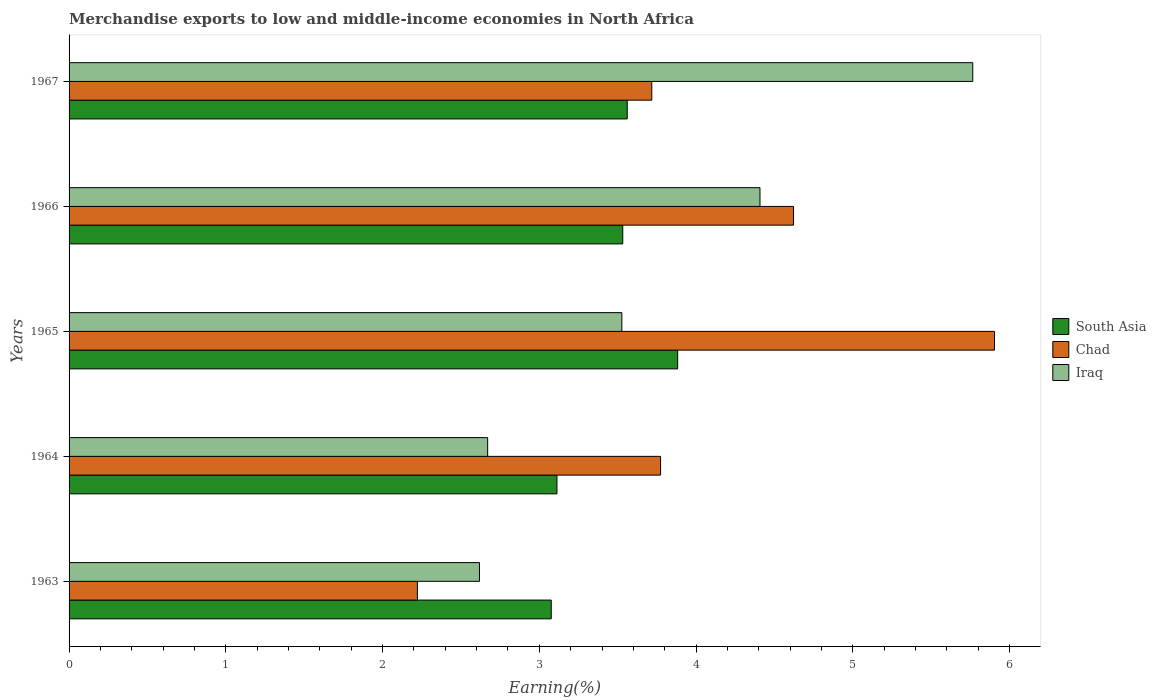How many groups of bars are there?
Provide a short and direct response. 5. Are the number of bars per tick equal to the number of legend labels?
Give a very brief answer. Yes. What is the label of the 1st group of bars from the top?
Your answer should be compact. 1967. In how many cases, is the number of bars for a given year not equal to the number of legend labels?
Your answer should be compact. 0. What is the percentage of amount earned from merchandise exports in Iraq in 1964?
Provide a succinct answer. 2.67. Across all years, what is the maximum percentage of amount earned from merchandise exports in Chad?
Your answer should be very brief. 5.9. Across all years, what is the minimum percentage of amount earned from merchandise exports in South Asia?
Offer a very short reply. 3.08. In which year was the percentage of amount earned from merchandise exports in Iraq maximum?
Provide a succinct answer. 1967. What is the total percentage of amount earned from merchandise exports in South Asia in the graph?
Make the answer very short. 17.16. What is the difference between the percentage of amount earned from merchandise exports in South Asia in 1963 and that in 1965?
Offer a very short reply. -0.81. What is the difference between the percentage of amount earned from merchandise exports in Chad in 1966 and the percentage of amount earned from merchandise exports in South Asia in 1963?
Your answer should be compact. 1.55. What is the average percentage of amount earned from merchandise exports in South Asia per year?
Make the answer very short. 3.43. In the year 1965, what is the difference between the percentage of amount earned from merchandise exports in Chad and percentage of amount earned from merchandise exports in Iraq?
Offer a very short reply. 2.38. In how many years, is the percentage of amount earned from merchandise exports in Iraq greater than 3.6 %?
Your response must be concise. 2. What is the ratio of the percentage of amount earned from merchandise exports in Chad in 1964 to that in 1967?
Offer a terse response. 1.02. What is the difference between the highest and the second highest percentage of amount earned from merchandise exports in Iraq?
Provide a succinct answer. 1.36. What is the difference between the highest and the lowest percentage of amount earned from merchandise exports in Chad?
Keep it short and to the point. 3.68. What does the 2nd bar from the top in 1966 represents?
Your answer should be very brief. Chad. What does the 3rd bar from the bottom in 1966 represents?
Offer a terse response. Iraq. What is the difference between two consecutive major ticks on the X-axis?
Give a very brief answer. 1. Does the graph contain any zero values?
Make the answer very short. No. What is the title of the graph?
Keep it short and to the point. Merchandise exports to low and middle-income economies in North Africa. What is the label or title of the X-axis?
Provide a short and direct response. Earning(%). What is the Earning(%) in South Asia in 1963?
Your answer should be very brief. 3.08. What is the Earning(%) in Chad in 1963?
Your response must be concise. 2.22. What is the Earning(%) of Iraq in 1963?
Your answer should be compact. 2.62. What is the Earning(%) of South Asia in 1964?
Give a very brief answer. 3.11. What is the Earning(%) of Chad in 1964?
Ensure brevity in your answer.  3.77. What is the Earning(%) in Iraq in 1964?
Your response must be concise. 2.67. What is the Earning(%) in South Asia in 1965?
Your answer should be very brief. 3.88. What is the Earning(%) in Chad in 1965?
Offer a terse response. 5.9. What is the Earning(%) in Iraq in 1965?
Provide a short and direct response. 3.53. What is the Earning(%) of South Asia in 1966?
Give a very brief answer. 3.53. What is the Earning(%) of Chad in 1966?
Make the answer very short. 4.62. What is the Earning(%) in Iraq in 1966?
Your answer should be compact. 4.41. What is the Earning(%) of South Asia in 1967?
Provide a short and direct response. 3.56. What is the Earning(%) in Chad in 1967?
Offer a very short reply. 3.72. What is the Earning(%) in Iraq in 1967?
Ensure brevity in your answer.  5.77. Across all years, what is the maximum Earning(%) of South Asia?
Your response must be concise. 3.88. Across all years, what is the maximum Earning(%) in Chad?
Offer a very short reply. 5.9. Across all years, what is the maximum Earning(%) in Iraq?
Your answer should be compact. 5.77. Across all years, what is the minimum Earning(%) of South Asia?
Keep it short and to the point. 3.08. Across all years, what is the minimum Earning(%) of Chad?
Ensure brevity in your answer.  2.22. Across all years, what is the minimum Earning(%) of Iraq?
Give a very brief answer. 2.62. What is the total Earning(%) of South Asia in the graph?
Keep it short and to the point. 17.16. What is the total Earning(%) in Chad in the graph?
Ensure brevity in your answer.  20.24. What is the total Earning(%) of Iraq in the graph?
Provide a short and direct response. 18.99. What is the difference between the Earning(%) in South Asia in 1963 and that in 1964?
Give a very brief answer. -0.04. What is the difference between the Earning(%) in Chad in 1963 and that in 1964?
Give a very brief answer. -1.55. What is the difference between the Earning(%) of Iraq in 1963 and that in 1964?
Ensure brevity in your answer.  -0.05. What is the difference between the Earning(%) of South Asia in 1963 and that in 1965?
Give a very brief answer. -0.81. What is the difference between the Earning(%) in Chad in 1963 and that in 1965?
Keep it short and to the point. -3.68. What is the difference between the Earning(%) in Iraq in 1963 and that in 1965?
Make the answer very short. -0.91. What is the difference between the Earning(%) in South Asia in 1963 and that in 1966?
Make the answer very short. -0.46. What is the difference between the Earning(%) in Chad in 1963 and that in 1966?
Provide a short and direct response. -2.4. What is the difference between the Earning(%) of Iraq in 1963 and that in 1966?
Ensure brevity in your answer.  -1.79. What is the difference between the Earning(%) of South Asia in 1963 and that in 1967?
Your answer should be compact. -0.48. What is the difference between the Earning(%) of Chad in 1963 and that in 1967?
Provide a succinct answer. -1.5. What is the difference between the Earning(%) of Iraq in 1963 and that in 1967?
Make the answer very short. -3.15. What is the difference between the Earning(%) of South Asia in 1964 and that in 1965?
Give a very brief answer. -0.77. What is the difference between the Earning(%) of Chad in 1964 and that in 1965?
Ensure brevity in your answer.  -2.13. What is the difference between the Earning(%) of Iraq in 1964 and that in 1965?
Keep it short and to the point. -0.86. What is the difference between the Earning(%) of South Asia in 1964 and that in 1966?
Give a very brief answer. -0.42. What is the difference between the Earning(%) of Chad in 1964 and that in 1966?
Make the answer very short. -0.85. What is the difference between the Earning(%) of Iraq in 1964 and that in 1966?
Your answer should be very brief. -1.74. What is the difference between the Earning(%) in South Asia in 1964 and that in 1967?
Ensure brevity in your answer.  -0.45. What is the difference between the Earning(%) of Chad in 1964 and that in 1967?
Provide a succinct answer. 0.06. What is the difference between the Earning(%) of Iraq in 1964 and that in 1967?
Provide a short and direct response. -3.09. What is the difference between the Earning(%) in South Asia in 1965 and that in 1966?
Give a very brief answer. 0.35. What is the difference between the Earning(%) of Chad in 1965 and that in 1966?
Your response must be concise. 1.28. What is the difference between the Earning(%) in Iraq in 1965 and that in 1966?
Provide a short and direct response. -0.88. What is the difference between the Earning(%) in South Asia in 1965 and that in 1967?
Make the answer very short. 0.32. What is the difference between the Earning(%) of Chad in 1965 and that in 1967?
Provide a succinct answer. 2.19. What is the difference between the Earning(%) of Iraq in 1965 and that in 1967?
Offer a terse response. -2.24. What is the difference between the Earning(%) in South Asia in 1966 and that in 1967?
Your answer should be very brief. -0.03. What is the difference between the Earning(%) in Chad in 1966 and that in 1967?
Offer a very short reply. 0.9. What is the difference between the Earning(%) in Iraq in 1966 and that in 1967?
Make the answer very short. -1.36. What is the difference between the Earning(%) of South Asia in 1963 and the Earning(%) of Chad in 1964?
Your answer should be compact. -0.7. What is the difference between the Earning(%) of South Asia in 1963 and the Earning(%) of Iraq in 1964?
Your answer should be compact. 0.41. What is the difference between the Earning(%) in Chad in 1963 and the Earning(%) in Iraq in 1964?
Provide a succinct answer. -0.45. What is the difference between the Earning(%) in South Asia in 1963 and the Earning(%) in Chad in 1965?
Ensure brevity in your answer.  -2.83. What is the difference between the Earning(%) in South Asia in 1963 and the Earning(%) in Iraq in 1965?
Your answer should be very brief. -0.45. What is the difference between the Earning(%) in Chad in 1963 and the Earning(%) in Iraq in 1965?
Offer a terse response. -1.3. What is the difference between the Earning(%) in South Asia in 1963 and the Earning(%) in Chad in 1966?
Offer a very short reply. -1.55. What is the difference between the Earning(%) of South Asia in 1963 and the Earning(%) of Iraq in 1966?
Provide a succinct answer. -1.33. What is the difference between the Earning(%) in Chad in 1963 and the Earning(%) in Iraq in 1966?
Make the answer very short. -2.19. What is the difference between the Earning(%) of South Asia in 1963 and the Earning(%) of Chad in 1967?
Ensure brevity in your answer.  -0.64. What is the difference between the Earning(%) in South Asia in 1963 and the Earning(%) in Iraq in 1967?
Your answer should be very brief. -2.69. What is the difference between the Earning(%) of Chad in 1963 and the Earning(%) of Iraq in 1967?
Ensure brevity in your answer.  -3.54. What is the difference between the Earning(%) of South Asia in 1964 and the Earning(%) of Chad in 1965?
Your answer should be very brief. -2.79. What is the difference between the Earning(%) of South Asia in 1964 and the Earning(%) of Iraq in 1965?
Ensure brevity in your answer.  -0.41. What is the difference between the Earning(%) in Chad in 1964 and the Earning(%) in Iraq in 1965?
Your answer should be compact. 0.25. What is the difference between the Earning(%) in South Asia in 1964 and the Earning(%) in Chad in 1966?
Offer a terse response. -1.51. What is the difference between the Earning(%) in South Asia in 1964 and the Earning(%) in Iraq in 1966?
Ensure brevity in your answer.  -1.3. What is the difference between the Earning(%) of Chad in 1964 and the Earning(%) of Iraq in 1966?
Offer a terse response. -0.63. What is the difference between the Earning(%) in South Asia in 1964 and the Earning(%) in Chad in 1967?
Make the answer very short. -0.6. What is the difference between the Earning(%) of South Asia in 1964 and the Earning(%) of Iraq in 1967?
Your answer should be compact. -2.65. What is the difference between the Earning(%) of Chad in 1964 and the Earning(%) of Iraq in 1967?
Make the answer very short. -1.99. What is the difference between the Earning(%) of South Asia in 1965 and the Earning(%) of Chad in 1966?
Your answer should be compact. -0.74. What is the difference between the Earning(%) in South Asia in 1965 and the Earning(%) in Iraq in 1966?
Your answer should be compact. -0.53. What is the difference between the Earning(%) in Chad in 1965 and the Earning(%) in Iraq in 1966?
Give a very brief answer. 1.5. What is the difference between the Earning(%) in South Asia in 1965 and the Earning(%) in Chad in 1967?
Give a very brief answer. 0.17. What is the difference between the Earning(%) of South Asia in 1965 and the Earning(%) of Iraq in 1967?
Provide a succinct answer. -1.88. What is the difference between the Earning(%) in Chad in 1965 and the Earning(%) in Iraq in 1967?
Give a very brief answer. 0.14. What is the difference between the Earning(%) in South Asia in 1966 and the Earning(%) in Chad in 1967?
Offer a very short reply. -0.19. What is the difference between the Earning(%) in South Asia in 1966 and the Earning(%) in Iraq in 1967?
Ensure brevity in your answer.  -2.23. What is the difference between the Earning(%) of Chad in 1966 and the Earning(%) of Iraq in 1967?
Give a very brief answer. -1.14. What is the average Earning(%) of South Asia per year?
Make the answer very short. 3.43. What is the average Earning(%) of Chad per year?
Provide a succinct answer. 4.05. What is the average Earning(%) of Iraq per year?
Keep it short and to the point. 3.8. In the year 1963, what is the difference between the Earning(%) of South Asia and Earning(%) of Chad?
Provide a short and direct response. 0.85. In the year 1963, what is the difference between the Earning(%) of South Asia and Earning(%) of Iraq?
Offer a terse response. 0.46. In the year 1963, what is the difference between the Earning(%) of Chad and Earning(%) of Iraq?
Your response must be concise. -0.4. In the year 1964, what is the difference between the Earning(%) of South Asia and Earning(%) of Chad?
Your answer should be very brief. -0.66. In the year 1964, what is the difference between the Earning(%) in South Asia and Earning(%) in Iraq?
Give a very brief answer. 0.44. In the year 1964, what is the difference between the Earning(%) of Chad and Earning(%) of Iraq?
Provide a succinct answer. 1.1. In the year 1965, what is the difference between the Earning(%) in South Asia and Earning(%) in Chad?
Your response must be concise. -2.02. In the year 1965, what is the difference between the Earning(%) of South Asia and Earning(%) of Iraq?
Offer a terse response. 0.36. In the year 1965, what is the difference between the Earning(%) in Chad and Earning(%) in Iraq?
Your answer should be compact. 2.38. In the year 1966, what is the difference between the Earning(%) in South Asia and Earning(%) in Chad?
Make the answer very short. -1.09. In the year 1966, what is the difference between the Earning(%) of South Asia and Earning(%) of Iraq?
Keep it short and to the point. -0.88. In the year 1966, what is the difference between the Earning(%) in Chad and Earning(%) in Iraq?
Keep it short and to the point. 0.21. In the year 1967, what is the difference between the Earning(%) in South Asia and Earning(%) in Chad?
Your answer should be compact. -0.16. In the year 1967, what is the difference between the Earning(%) of South Asia and Earning(%) of Iraq?
Ensure brevity in your answer.  -2.2. In the year 1967, what is the difference between the Earning(%) in Chad and Earning(%) in Iraq?
Your response must be concise. -2.05. What is the ratio of the Earning(%) of South Asia in 1963 to that in 1964?
Give a very brief answer. 0.99. What is the ratio of the Earning(%) of Chad in 1963 to that in 1964?
Give a very brief answer. 0.59. What is the ratio of the Earning(%) in Iraq in 1963 to that in 1964?
Make the answer very short. 0.98. What is the ratio of the Earning(%) of South Asia in 1963 to that in 1965?
Ensure brevity in your answer.  0.79. What is the ratio of the Earning(%) in Chad in 1963 to that in 1965?
Offer a terse response. 0.38. What is the ratio of the Earning(%) of Iraq in 1963 to that in 1965?
Provide a short and direct response. 0.74. What is the ratio of the Earning(%) in South Asia in 1963 to that in 1966?
Provide a succinct answer. 0.87. What is the ratio of the Earning(%) in Chad in 1963 to that in 1966?
Your response must be concise. 0.48. What is the ratio of the Earning(%) in Iraq in 1963 to that in 1966?
Your response must be concise. 0.59. What is the ratio of the Earning(%) of South Asia in 1963 to that in 1967?
Provide a succinct answer. 0.86. What is the ratio of the Earning(%) of Chad in 1963 to that in 1967?
Provide a short and direct response. 0.6. What is the ratio of the Earning(%) of Iraq in 1963 to that in 1967?
Provide a short and direct response. 0.45. What is the ratio of the Earning(%) in South Asia in 1964 to that in 1965?
Offer a terse response. 0.8. What is the ratio of the Earning(%) of Chad in 1964 to that in 1965?
Provide a short and direct response. 0.64. What is the ratio of the Earning(%) of Iraq in 1964 to that in 1965?
Your answer should be very brief. 0.76. What is the ratio of the Earning(%) of South Asia in 1964 to that in 1966?
Your answer should be compact. 0.88. What is the ratio of the Earning(%) of Chad in 1964 to that in 1966?
Offer a terse response. 0.82. What is the ratio of the Earning(%) in Iraq in 1964 to that in 1966?
Ensure brevity in your answer.  0.61. What is the ratio of the Earning(%) in South Asia in 1964 to that in 1967?
Ensure brevity in your answer.  0.87. What is the ratio of the Earning(%) in Chad in 1964 to that in 1967?
Offer a very short reply. 1.02. What is the ratio of the Earning(%) in Iraq in 1964 to that in 1967?
Offer a terse response. 0.46. What is the ratio of the Earning(%) in South Asia in 1965 to that in 1966?
Offer a terse response. 1.1. What is the ratio of the Earning(%) of Chad in 1965 to that in 1966?
Provide a succinct answer. 1.28. What is the ratio of the Earning(%) of South Asia in 1965 to that in 1967?
Ensure brevity in your answer.  1.09. What is the ratio of the Earning(%) in Chad in 1965 to that in 1967?
Keep it short and to the point. 1.59. What is the ratio of the Earning(%) in Iraq in 1965 to that in 1967?
Provide a short and direct response. 0.61. What is the ratio of the Earning(%) in South Asia in 1966 to that in 1967?
Make the answer very short. 0.99. What is the ratio of the Earning(%) in Chad in 1966 to that in 1967?
Your answer should be very brief. 1.24. What is the ratio of the Earning(%) of Iraq in 1966 to that in 1967?
Your response must be concise. 0.76. What is the difference between the highest and the second highest Earning(%) in South Asia?
Offer a very short reply. 0.32. What is the difference between the highest and the second highest Earning(%) of Chad?
Offer a terse response. 1.28. What is the difference between the highest and the second highest Earning(%) of Iraq?
Keep it short and to the point. 1.36. What is the difference between the highest and the lowest Earning(%) in South Asia?
Make the answer very short. 0.81. What is the difference between the highest and the lowest Earning(%) of Chad?
Your response must be concise. 3.68. What is the difference between the highest and the lowest Earning(%) of Iraq?
Your response must be concise. 3.15. 